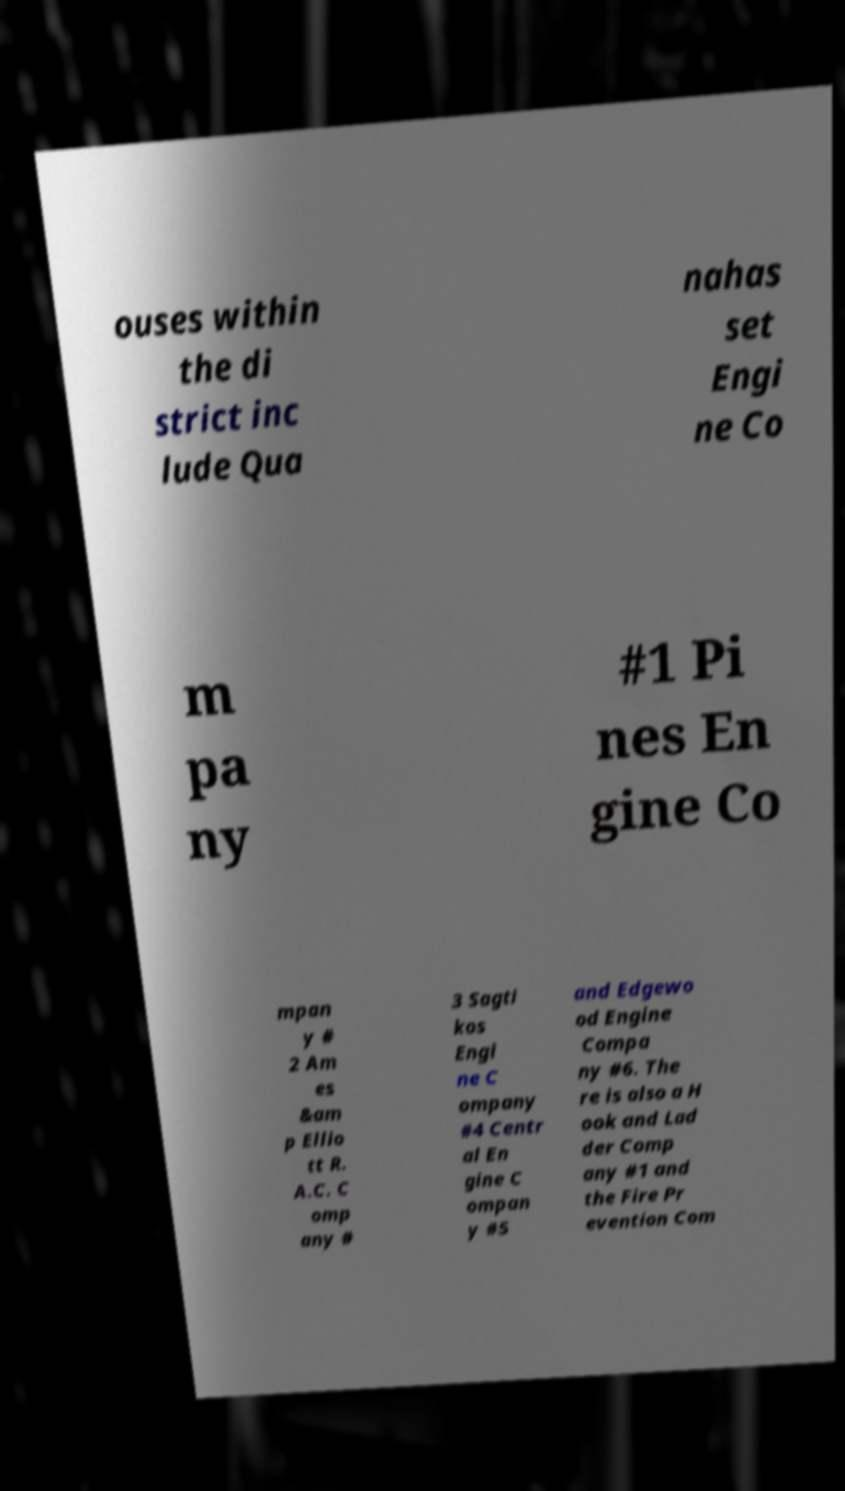Please read and relay the text visible in this image. What does it say? ouses within the di strict inc lude Qua nahas set Engi ne Co m pa ny #1 Pi nes En gine Co mpan y # 2 Am es &am p Ellio tt R. A.C. C omp any # 3 Sagti kos Engi ne C ompany #4 Centr al En gine C ompan y #5 and Edgewo od Engine Compa ny #6. The re is also a H ook and Lad der Comp any #1 and the Fire Pr evention Com 